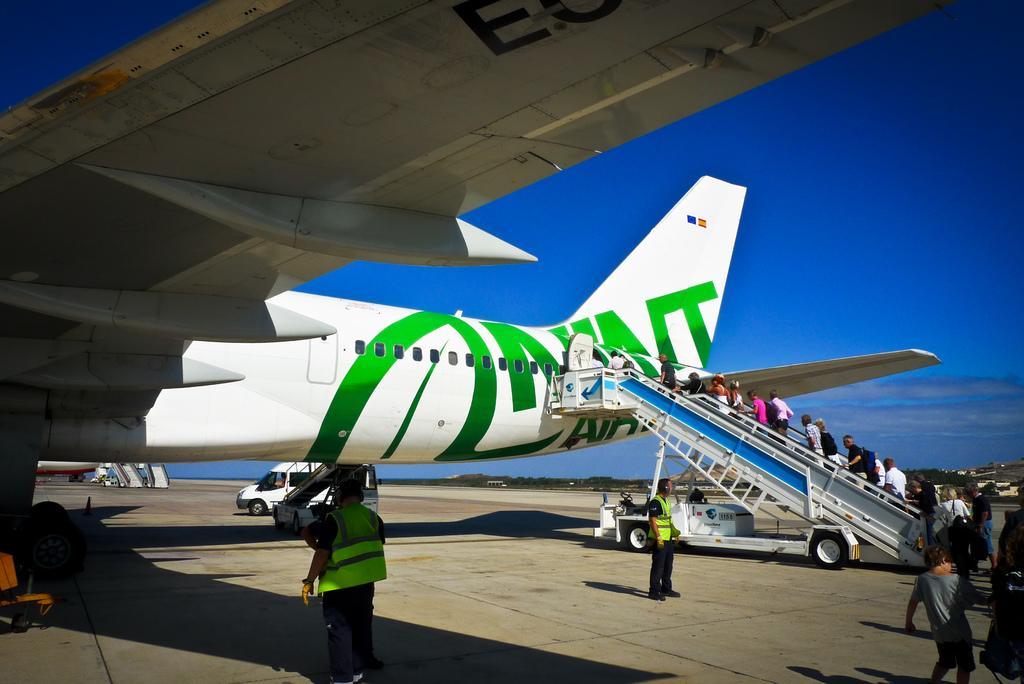In one or two sentences, can you explain what this image depicts? In this image we can see people, plane, road, and vehicles. In the background there is sky with clouds. 